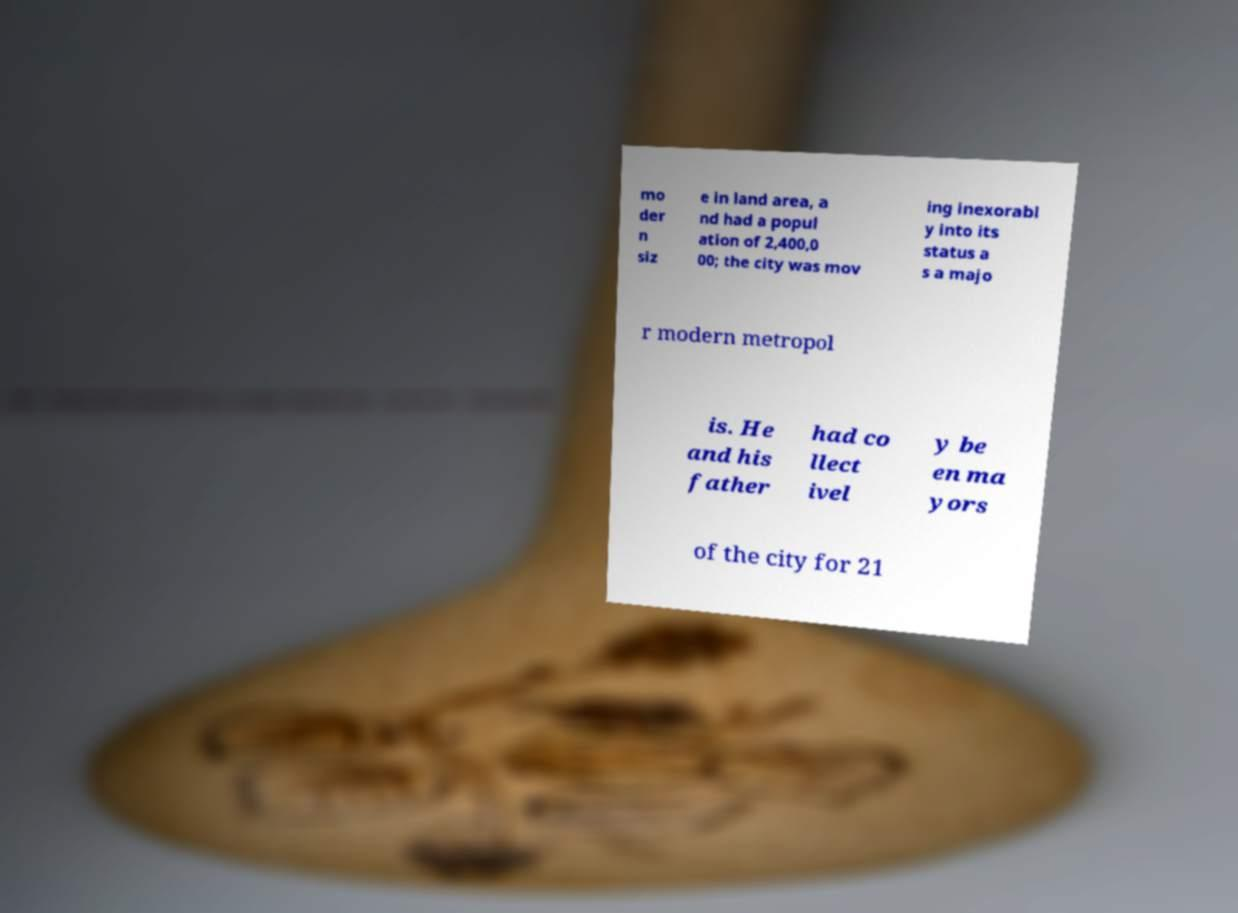Could you assist in decoding the text presented in this image and type it out clearly? mo der n siz e in land area, a nd had a popul ation of 2,400,0 00; the city was mov ing inexorabl y into its status a s a majo r modern metropol is. He and his father had co llect ivel y be en ma yors of the city for 21 